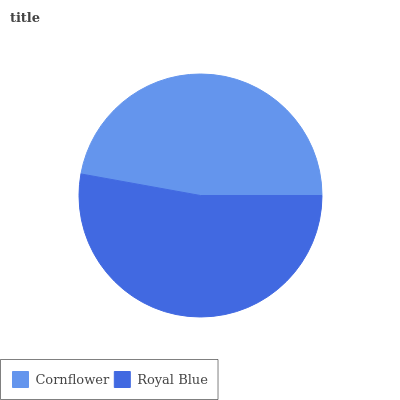Is Cornflower the minimum?
Answer yes or no. Yes. Is Royal Blue the maximum?
Answer yes or no. Yes. Is Royal Blue the minimum?
Answer yes or no. No. Is Royal Blue greater than Cornflower?
Answer yes or no. Yes. Is Cornflower less than Royal Blue?
Answer yes or no. Yes. Is Cornflower greater than Royal Blue?
Answer yes or no. No. Is Royal Blue less than Cornflower?
Answer yes or no. No. Is Royal Blue the high median?
Answer yes or no. Yes. Is Cornflower the low median?
Answer yes or no. Yes. Is Cornflower the high median?
Answer yes or no. No. Is Royal Blue the low median?
Answer yes or no. No. 